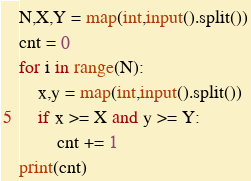<code> <loc_0><loc_0><loc_500><loc_500><_Python_>N,X,Y = map(int,input().split())
cnt = 0
for i in range(N):
    x,y = map(int,input().split())
    if x >= X and y >= Y:
        cnt += 1
print(cnt)</code> 